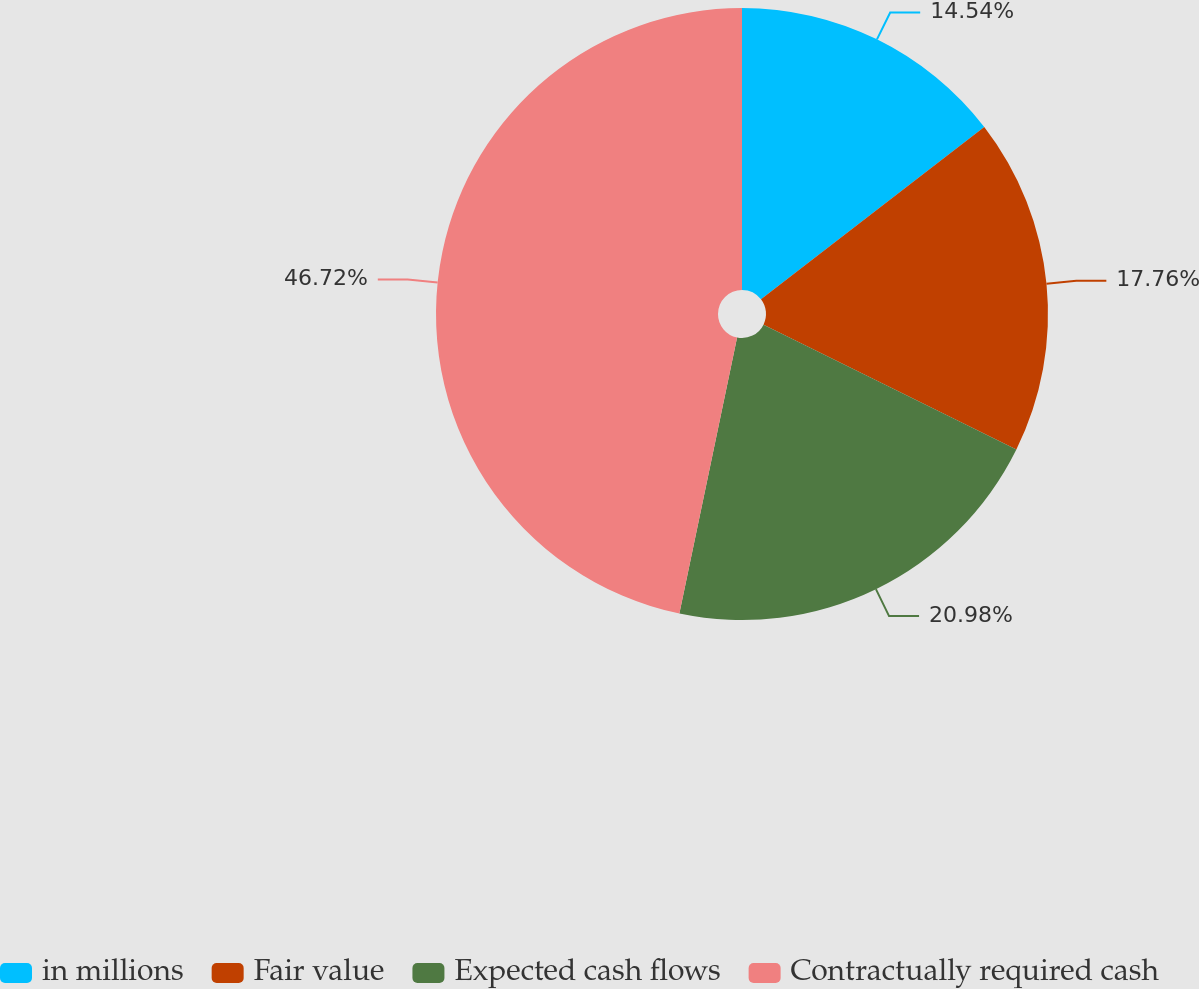<chart> <loc_0><loc_0><loc_500><loc_500><pie_chart><fcel>in millions<fcel>Fair value<fcel>Expected cash flows<fcel>Contractually required cash<nl><fcel>14.54%<fcel>17.76%<fcel>20.98%<fcel>46.72%<nl></chart> 